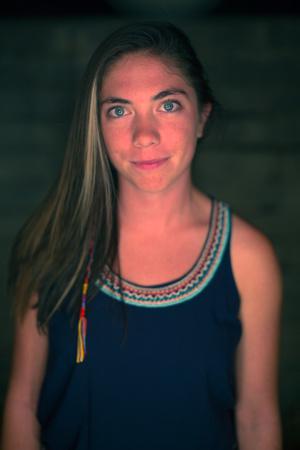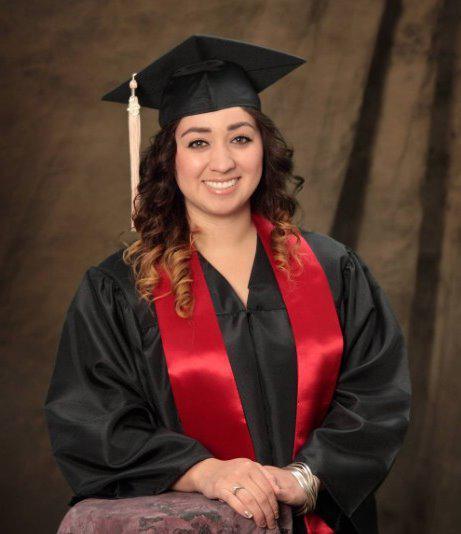The first image is the image on the left, the second image is the image on the right. For the images shown, is this caption "One image shows a brunette female grasping the black tassel on her graduation cap." true? Answer yes or no. No. The first image is the image on the left, the second image is the image on the right. Considering the images on both sides, is "A mona is holding the tassel on her mortarboard." valid? Answer yes or no. No. 